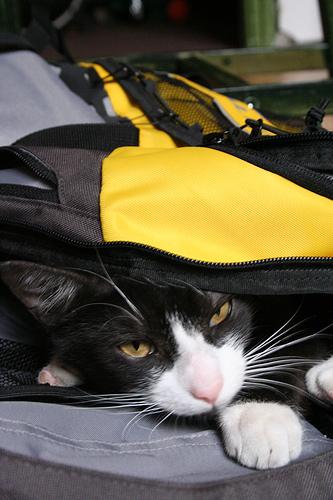What is the cat in?
Short answer required. Backpack. What color is the cat?
Give a very brief answer. Black and white. What color is the cat's eyes?
Short answer required. Yellow. 